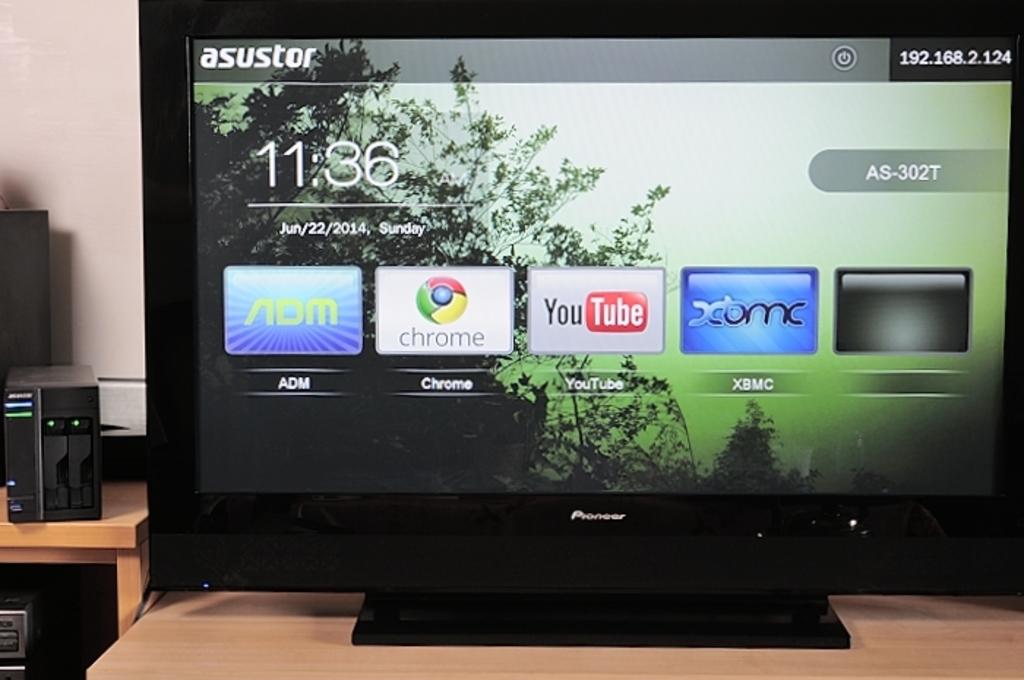What is the third app shown?
Your answer should be very brief. Youtube. What time is shown on the screen?
Keep it short and to the point. 11:36. 